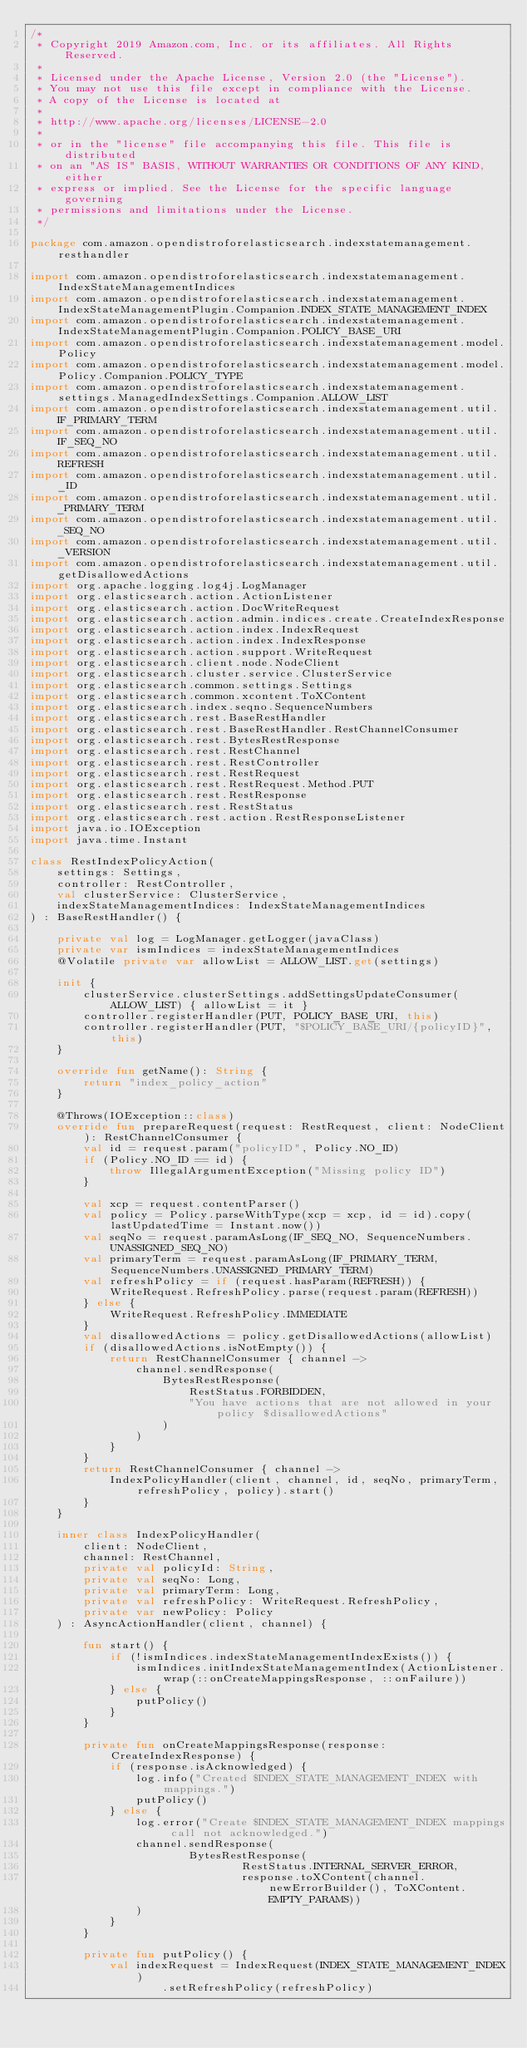<code> <loc_0><loc_0><loc_500><loc_500><_Kotlin_>/*
 * Copyright 2019 Amazon.com, Inc. or its affiliates. All Rights Reserved.
 *
 * Licensed under the Apache License, Version 2.0 (the "License").
 * You may not use this file except in compliance with the License.
 * A copy of the License is located at
 *
 * http://www.apache.org/licenses/LICENSE-2.0
 *
 * or in the "license" file accompanying this file. This file is distributed
 * on an "AS IS" BASIS, WITHOUT WARRANTIES OR CONDITIONS OF ANY KIND, either
 * express or implied. See the License for the specific language governing
 * permissions and limitations under the License.
 */

package com.amazon.opendistroforelasticsearch.indexstatemanagement.resthandler

import com.amazon.opendistroforelasticsearch.indexstatemanagement.IndexStateManagementIndices
import com.amazon.opendistroforelasticsearch.indexstatemanagement.IndexStateManagementPlugin.Companion.INDEX_STATE_MANAGEMENT_INDEX
import com.amazon.opendistroforelasticsearch.indexstatemanagement.IndexStateManagementPlugin.Companion.POLICY_BASE_URI
import com.amazon.opendistroforelasticsearch.indexstatemanagement.model.Policy
import com.amazon.opendistroforelasticsearch.indexstatemanagement.model.Policy.Companion.POLICY_TYPE
import com.amazon.opendistroforelasticsearch.indexstatemanagement.settings.ManagedIndexSettings.Companion.ALLOW_LIST
import com.amazon.opendistroforelasticsearch.indexstatemanagement.util.IF_PRIMARY_TERM
import com.amazon.opendistroforelasticsearch.indexstatemanagement.util.IF_SEQ_NO
import com.amazon.opendistroforelasticsearch.indexstatemanagement.util.REFRESH
import com.amazon.opendistroforelasticsearch.indexstatemanagement.util._ID
import com.amazon.opendistroforelasticsearch.indexstatemanagement.util._PRIMARY_TERM
import com.amazon.opendistroforelasticsearch.indexstatemanagement.util._SEQ_NO
import com.amazon.opendistroforelasticsearch.indexstatemanagement.util._VERSION
import com.amazon.opendistroforelasticsearch.indexstatemanagement.util.getDisallowedActions
import org.apache.logging.log4j.LogManager
import org.elasticsearch.action.ActionListener
import org.elasticsearch.action.DocWriteRequest
import org.elasticsearch.action.admin.indices.create.CreateIndexResponse
import org.elasticsearch.action.index.IndexRequest
import org.elasticsearch.action.index.IndexResponse
import org.elasticsearch.action.support.WriteRequest
import org.elasticsearch.client.node.NodeClient
import org.elasticsearch.cluster.service.ClusterService
import org.elasticsearch.common.settings.Settings
import org.elasticsearch.common.xcontent.ToXContent
import org.elasticsearch.index.seqno.SequenceNumbers
import org.elasticsearch.rest.BaseRestHandler
import org.elasticsearch.rest.BaseRestHandler.RestChannelConsumer
import org.elasticsearch.rest.BytesRestResponse
import org.elasticsearch.rest.RestChannel
import org.elasticsearch.rest.RestController
import org.elasticsearch.rest.RestRequest
import org.elasticsearch.rest.RestRequest.Method.PUT
import org.elasticsearch.rest.RestResponse
import org.elasticsearch.rest.RestStatus
import org.elasticsearch.rest.action.RestResponseListener
import java.io.IOException
import java.time.Instant

class RestIndexPolicyAction(
    settings: Settings,
    controller: RestController,
    val clusterService: ClusterService,
    indexStateManagementIndices: IndexStateManagementIndices
) : BaseRestHandler() {

    private val log = LogManager.getLogger(javaClass)
    private var ismIndices = indexStateManagementIndices
    @Volatile private var allowList = ALLOW_LIST.get(settings)

    init {
        clusterService.clusterSettings.addSettingsUpdateConsumer(ALLOW_LIST) { allowList = it }
        controller.registerHandler(PUT, POLICY_BASE_URI, this)
        controller.registerHandler(PUT, "$POLICY_BASE_URI/{policyID}", this)
    }

    override fun getName(): String {
        return "index_policy_action"
    }

    @Throws(IOException::class)
    override fun prepareRequest(request: RestRequest, client: NodeClient): RestChannelConsumer {
        val id = request.param("policyID", Policy.NO_ID)
        if (Policy.NO_ID == id) {
            throw IllegalArgumentException("Missing policy ID")
        }

        val xcp = request.contentParser()
        val policy = Policy.parseWithType(xcp = xcp, id = id).copy(lastUpdatedTime = Instant.now())
        val seqNo = request.paramAsLong(IF_SEQ_NO, SequenceNumbers.UNASSIGNED_SEQ_NO)
        val primaryTerm = request.paramAsLong(IF_PRIMARY_TERM, SequenceNumbers.UNASSIGNED_PRIMARY_TERM)
        val refreshPolicy = if (request.hasParam(REFRESH)) {
            WriteRequest.RefreshPolicy.parse(request.param(REFRESH))
        } else {
            WriteRequest.RefreshPolicy.IMMEDIATE
        }
        val disallowedActions = policy.getDisallowedActions(allowList)
        if (disallowedActions.isNotEmpty()) {
            return RestChannelConsumer { channel ->
                channel.sendResponse(
                    BytesRestResponse(
                        RestStatus.FORBIDDEN,
                        "You have actions that are not allowed in your policy $disallowedActions"
                    )
                )
            }
        }
        return RestChannelConsumer { channel ->
            IndexPolicyHandler(client, channel, id, seqNo, primaryTerm, refreshPolicy, policy).start()
        }
    }

    inner class IndexPolicyHandler(
        client: NodeClient,
        channel: RestChannel,
        private val policyId: String,
        private val seqNo: Long,
        private val primaryTerm: Long,
        private val refreshPolicy: WriteRequest.RefreshPolicy,
        private var newPolicy: Policy
    ) : AsyncActionHandler(client, channel) {

        fun start() {
            if (!ismIndices.indexStateManagementIndexExists()) {
                ismIndices.initIndexStateManagementIndex(ActionListener.wrap(::onCreateMappingsResponse, ::onFailure))
            } else {
                putPolicy()
            }
        }

        private fun onCreateMappingsResponse(response: CreateIndexResponse) {
            if (response.isAcknowledged) {
                log.info("Created $INDEX_STATE_MANAGEMENT_INDEX with mappings.")
                putPolicy()
            } else {
                log.error("Create $INDEX_STATE_MANAGEMENT_INDEX mappings call not acknowledged.")
                channel.sendResponse(
                        BytesRestResponse(
                                RestStatus.INTERNAL_SERVER_ERROR,
                                response.toXContent(channel.newErrorBuilder(), ToXContent.EMPTY_PARAMS))
                )
            }
        }

        private fun putPolicy() {
            val indexRequest = IndexRequest(INDEX_STATE_MANAGEMENT_INDEX)
                    .setRefreshPolicy(refreshPolicy)</code> 